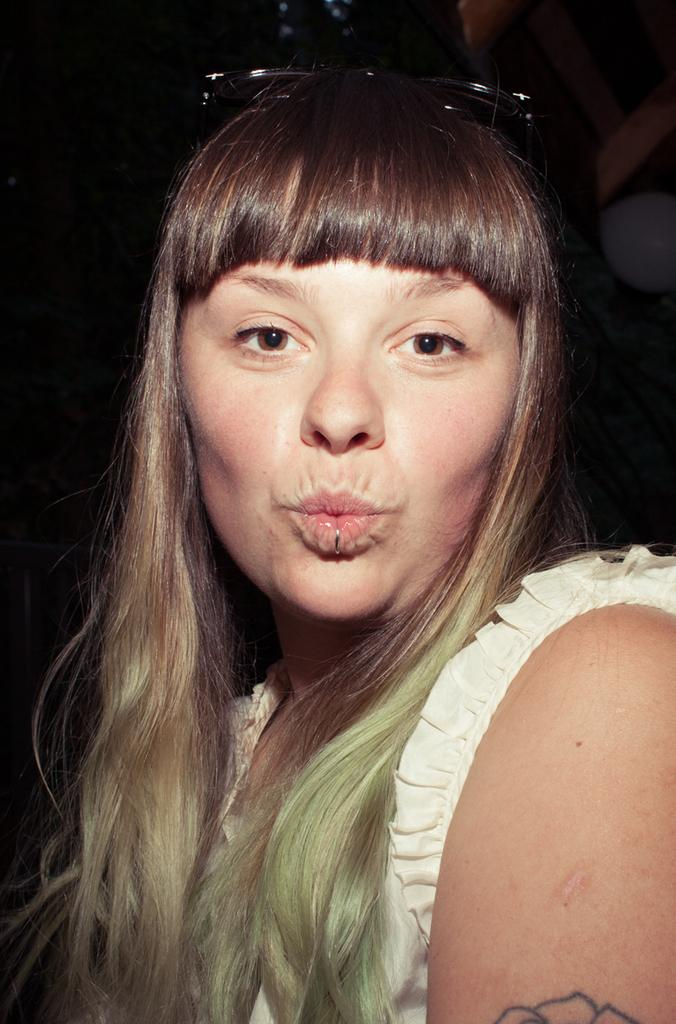Who is the main subject in the foreground of the image? There is a woman in the foreground of the image. What can be seen in the background of the image? The background of the image is black. What type of lettuce is being used for the activity in the image? There is no lettuce or activity present in the image; it features a woman in the foreground and a black background. 